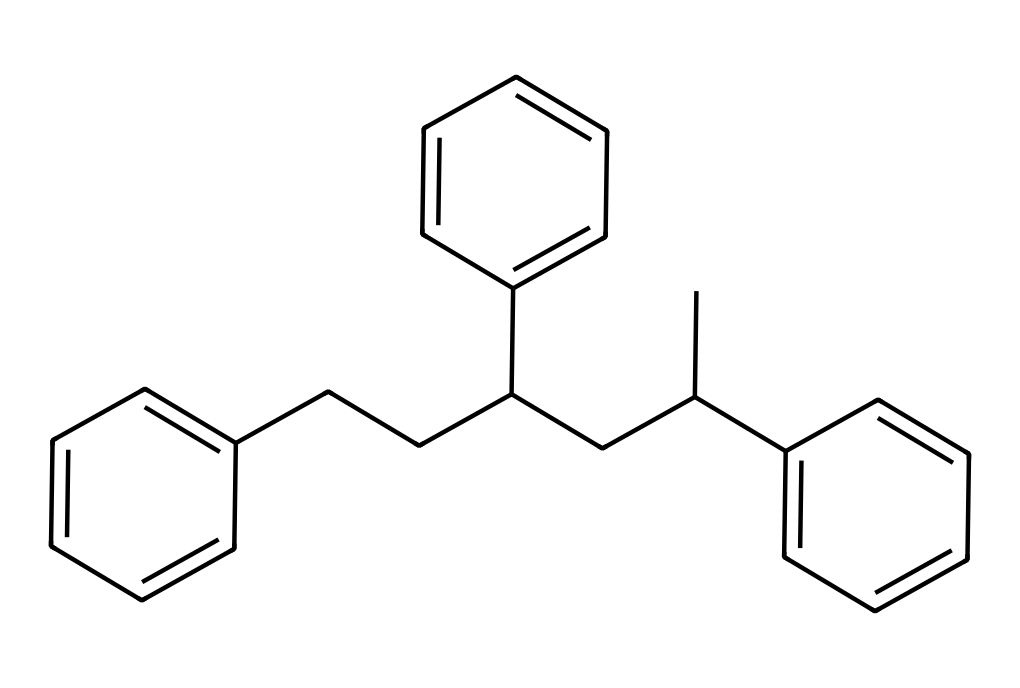How many distinct benzene rings are present in this structure? The chemical structure shows multiple cycles of carbon atoms, specifically three distinct cycles comprising six carbon atoms each, characteristic of benzene rings. Thus, there are three separate benzene rings in the overall structure.
Answer: three What type of polymer is represented here? The chemical structure includes repeating units of styrene, pointing to a polystyrene polymer, a thermoplastic commonly used in disposable products like coffee cups.
Answer: polystyrene How many carbon atoms are present in the entire structure? To find the total number of carbon atoms, we can count the carbon atoms in the cyclohexane-like structures and the branched chains. Each benzene contributes six carbons, and additional branched alkyl chains contribute a few more, leading to a total of 18 carbon atoms in the structure.
Answer: eighteen What type of bonding primarily holds the structure of polystyrene together? The primary type of bonding in polystyrene is covalent bonding, which occurs between the carbon atoms in the polymer chain and within the benzene rings, providing structural integrity.
Answer: covalent What characteristic does the presence of aromatic rings impart to polystyrene? The presence of aromatic rings in the chemical structure allows for increased stability and rigidity due to resonance, which contributes to the overall properties of polystyrene as a solid and durable material.
Answer: stability 